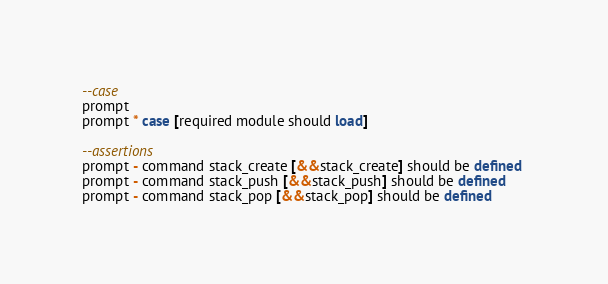Convert code to text. <code><loc_0><loc_0><loc_500><loc_500><_SQL_>--case
prompt
prompt * case [required module should load]

--assertions
prompt - command stack_create [&&stack_create] should be defined 
prompt - command stack_push [&&stack_push] should be defined 
prompt - command stack_pop [&&stack_pop] should be defined
</code> 